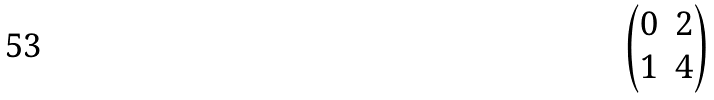Convert formula to latex. <formula><loc_0><loc_0><loc_500><loc_500>\begin{pmatrix} 0 & 2 \\ 1 & 4 \end{pmatrix}</formula> 